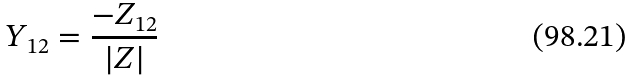<formula> <loc_0><loc_0><loc_500><loc_500>Y _ { 1 2 } = \frac { - Z _ { 1 2 } } { | Z | }</formula> 